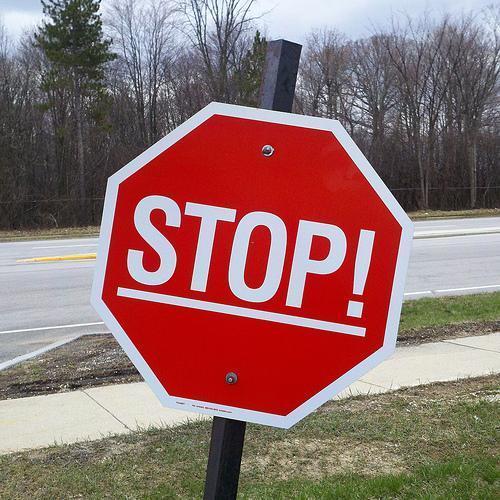How many stop signs are there?
Give a very brief answer. 1. How many letters are on the stop sign?
Give a very brief answer. 4. How many sides does the stop sign have?
Give a very brief answer. 8. 